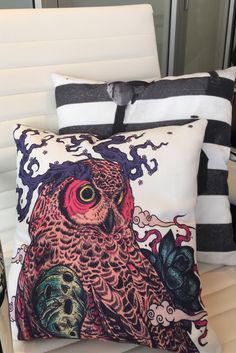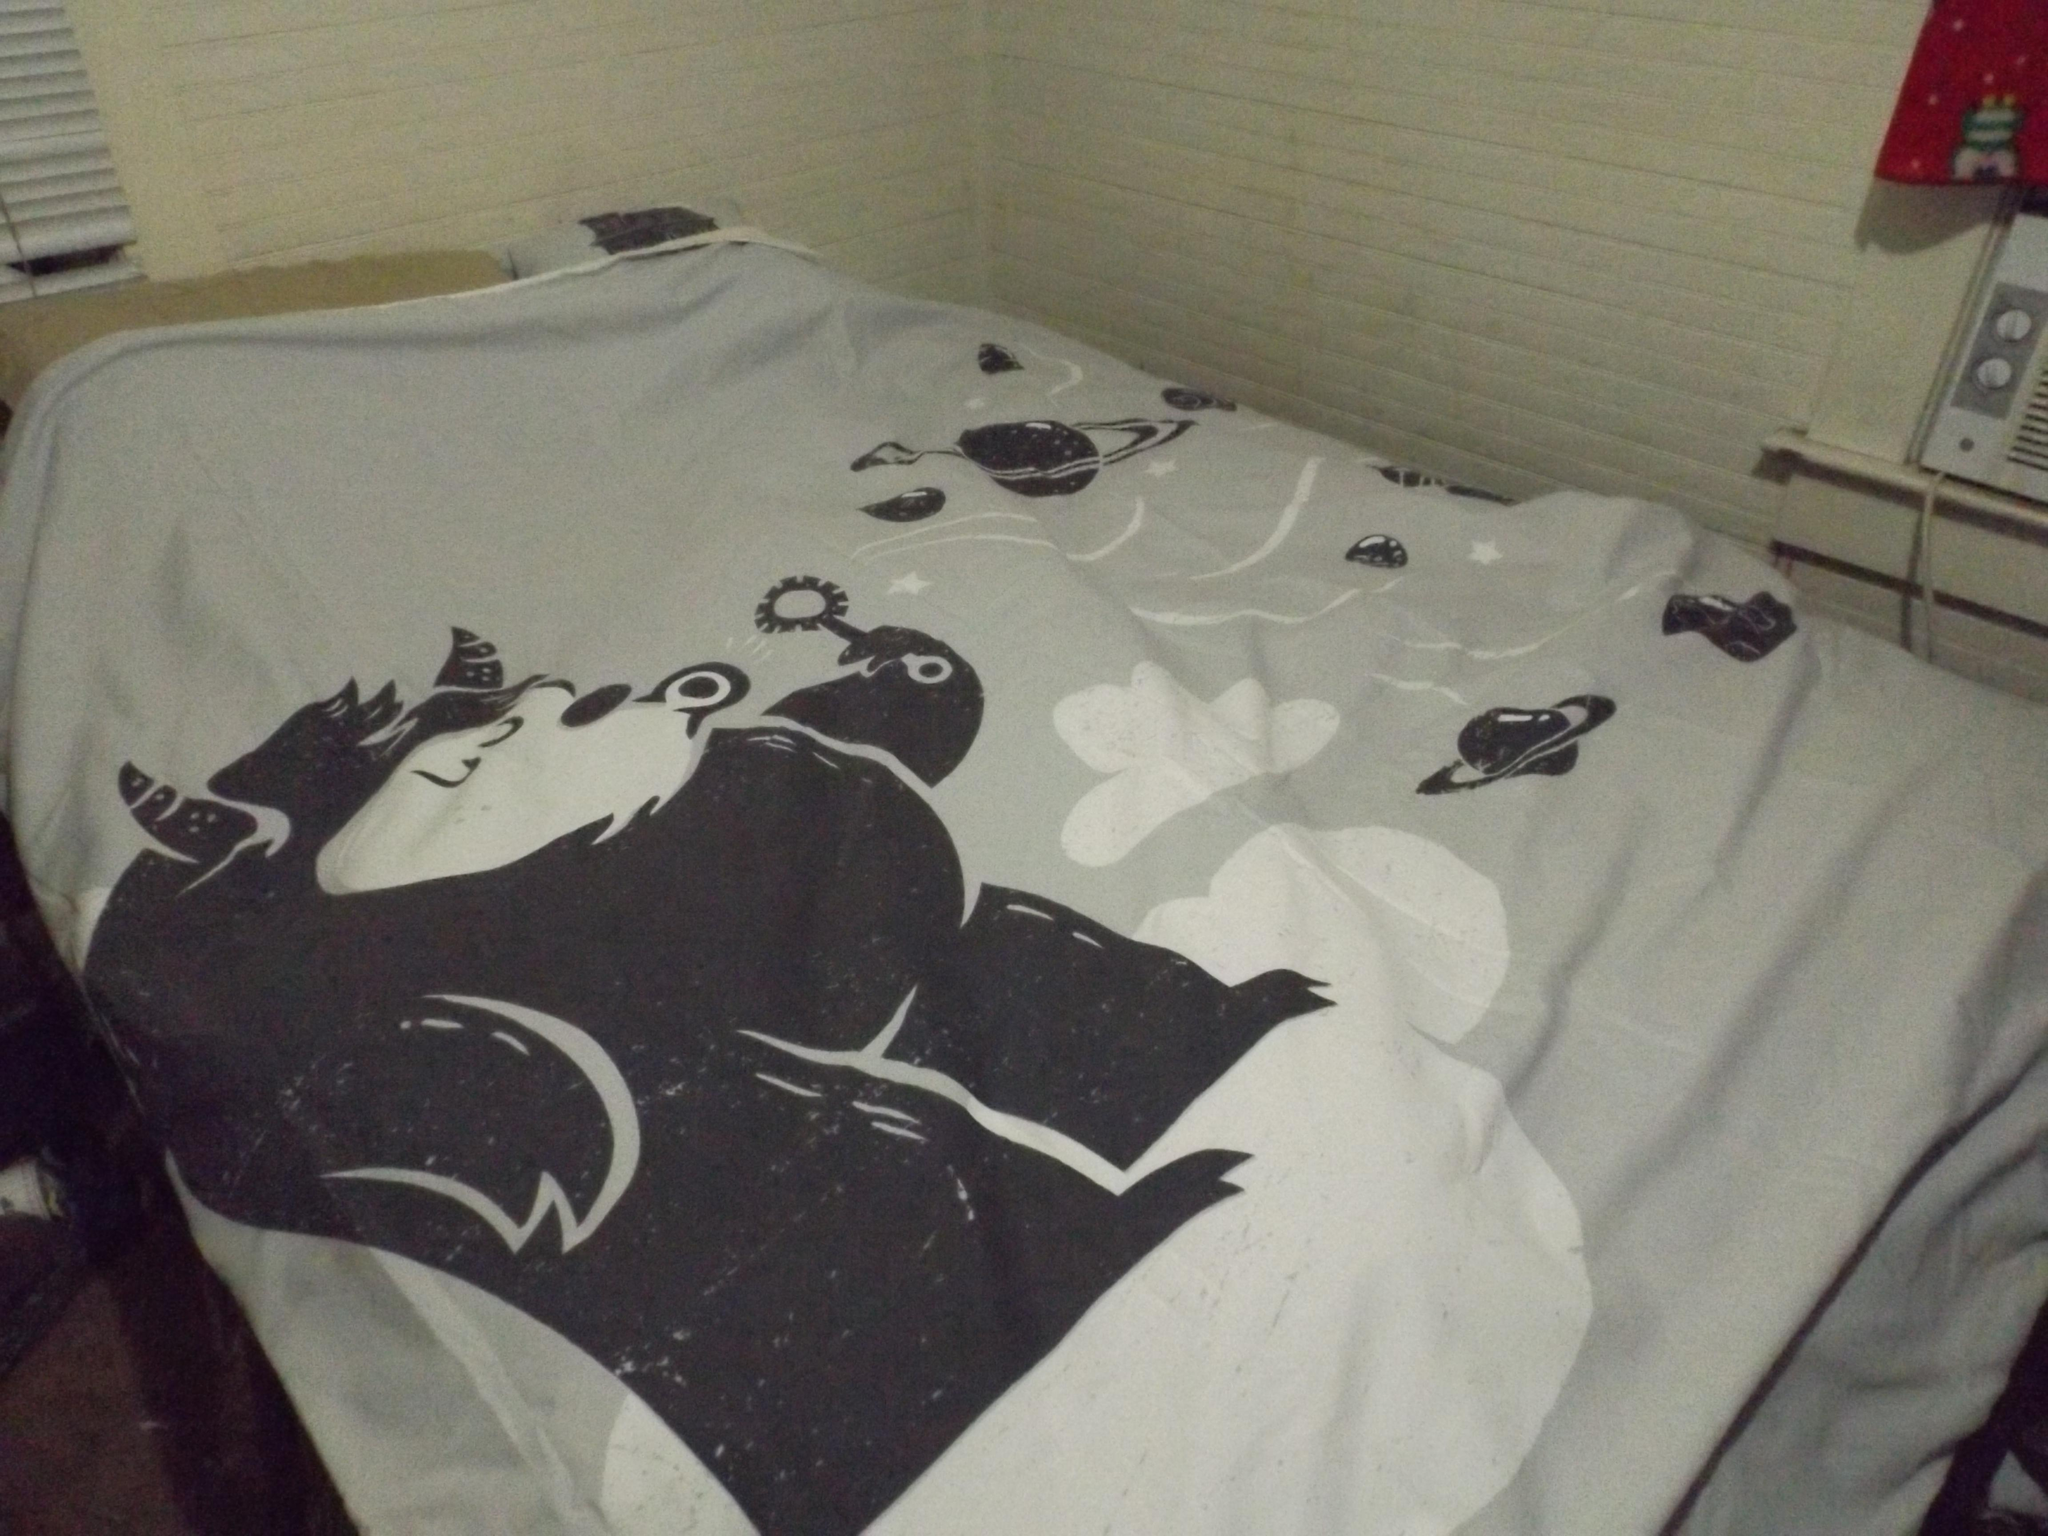The first image is the image on the left, the second image is the image on the right. Examine the images to the left and right. Is the description "There are at least five pillows, more in one image than the other." accurate? Answer yes or no. No. The first image is the image on the left, the second image is the image on the right. Evaluate the accuracy of this statement regarding the images: "An image shows a printed bedspread with no throw pillows on top or people under it.". Is it true? Answer yes or no. Yes. 